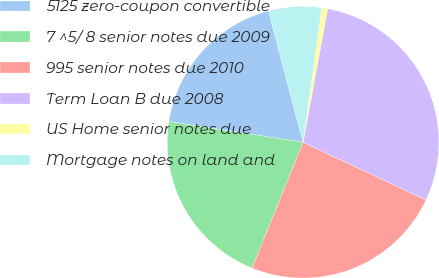Convert chart to OTSL. <chart><loc_0><loc_0><loc_500><loc_500><pie_chart><fcel>5125 zero-coupon convertible<fcel>7 ^5/ 8 senior notes due 2009<fcel>995 senior notes due 2010<fcel>Term Loan B due 2008<fcel>US Home senior notes due<fcel>Mortgage notes on land and<nl><fcel>18.47%<fcel>21.31%<fcel>24.15%<fcel>29.1%<fcel>0.7%<fcel>6.29%<nl></chart> 